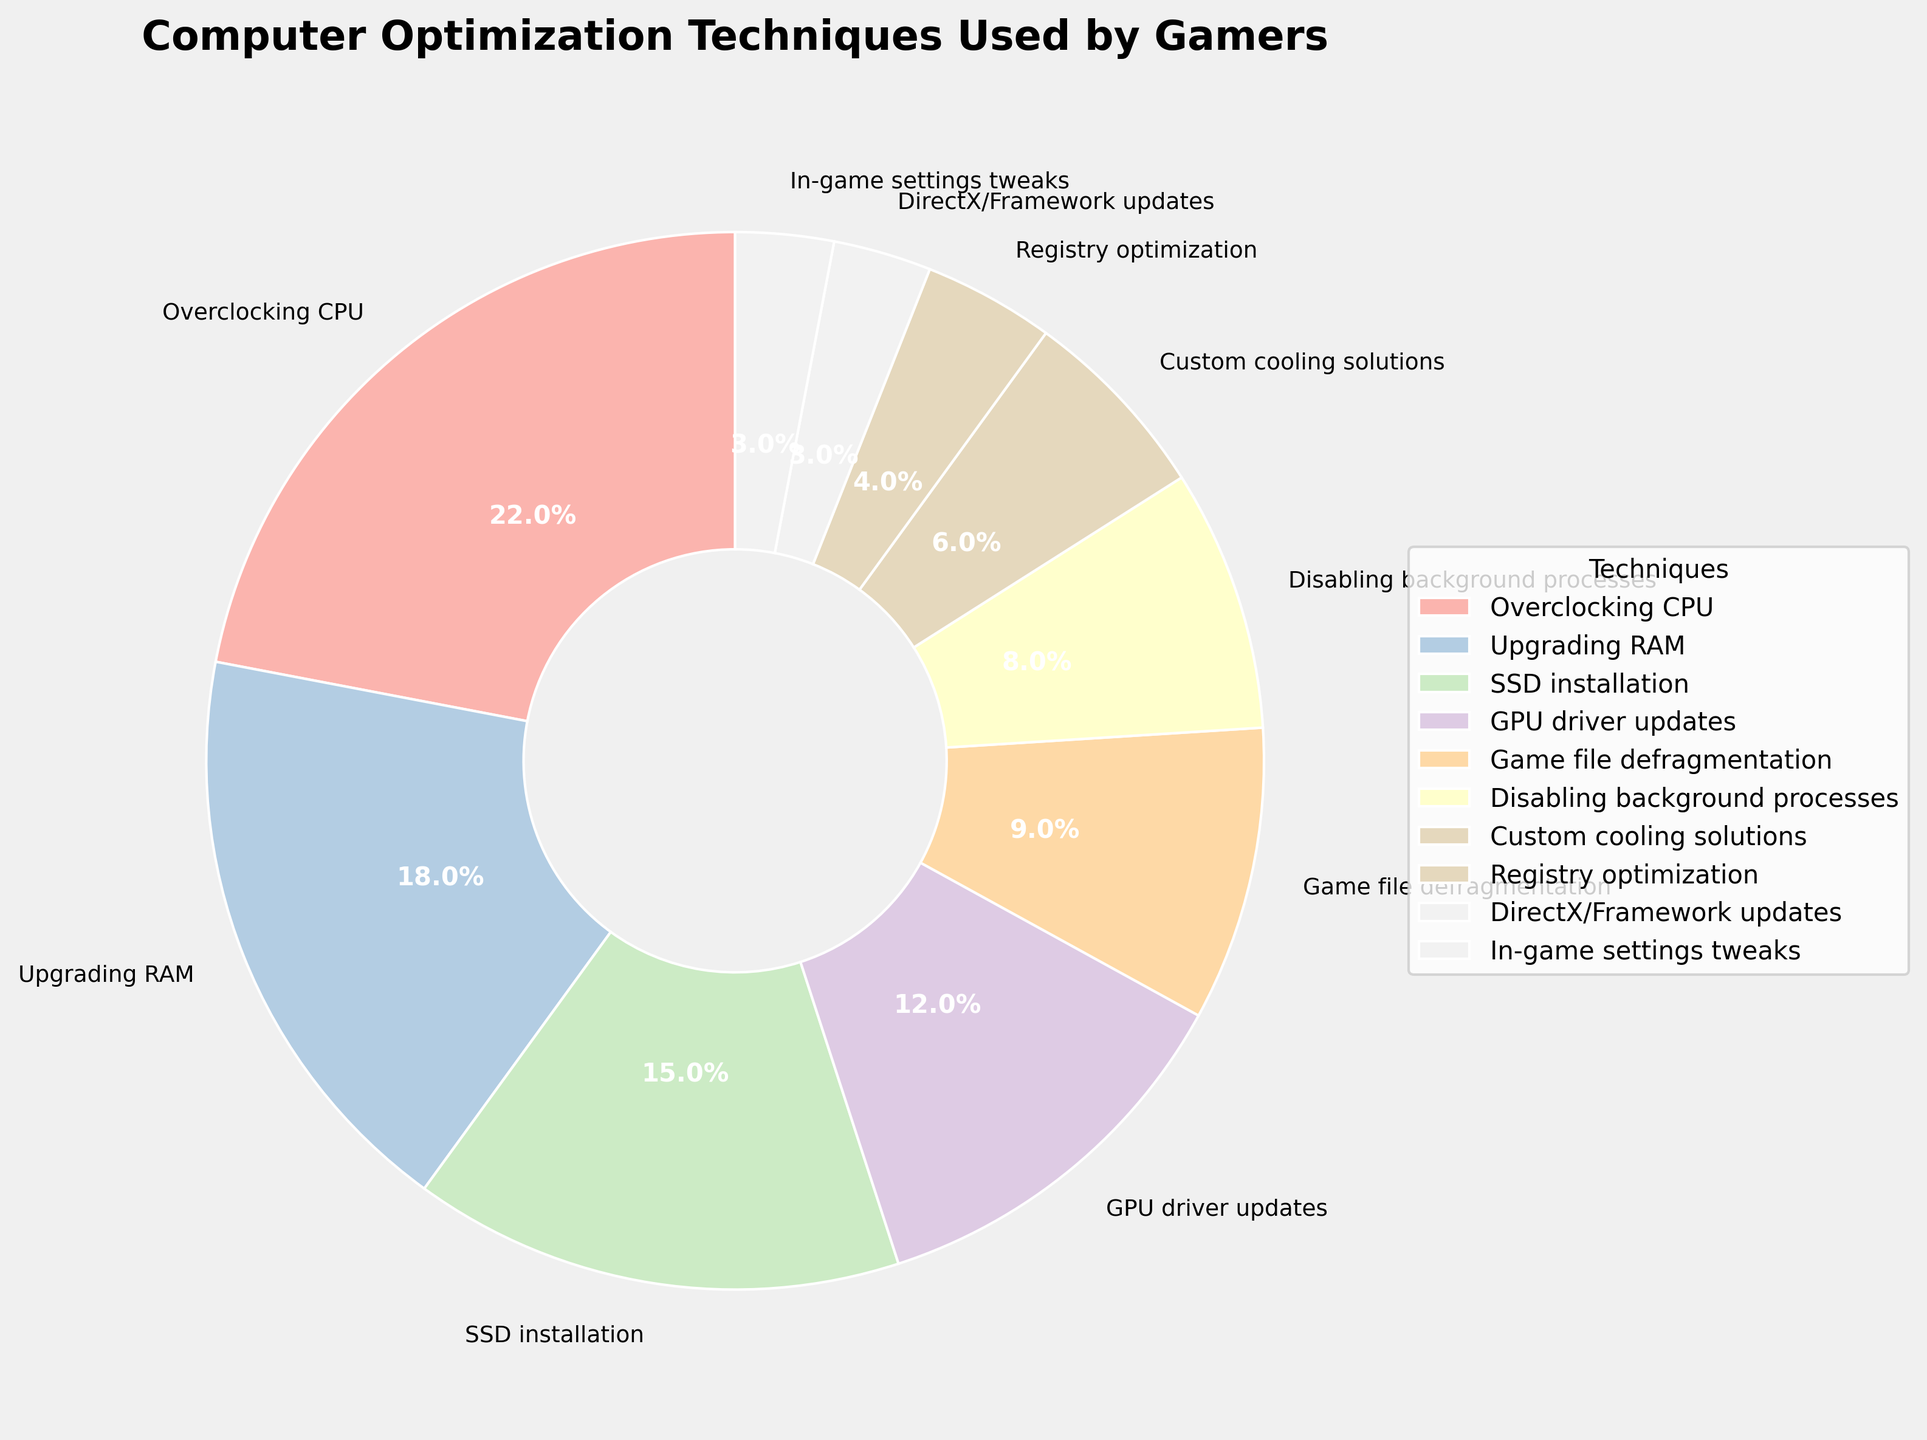What percentage of gamers use SSD installation as an optimization technique? Look at the slice labeled "SSD installation" and find its percentage.
Answer: 15% Which technique is used by more gamers, upgrading RAM or GPU driver updates? Compare the percentages of "Upgrading RAM" and "GPU driver updates". RAM has 18%, GPU drivers have 12%.
Answer: Upgrading RAM What’s the total percentage of gamers that use overclocking CPU, upgrading RAM, and SSD installation? Sum the percentages of "Overclocking CPU (22%)", "Upgrading RAM (18%)", and "SSD installation (15%)". So, 22 + 18 + 15 = 55%.
Answer: 55% Are there any techniques used by less than 5% of gamers? If so, which ones? Scan the slices for percentages less than 5%. Both "Registry optimization" and "In-game settings tweaks" are at 4% and 3% respectively.
Answer: Registry optimization, In-game settings tweaks What percentage of gamers use techniques related to cooling solutions and what visually distinguishes that slice? The percentage for "Custom cooling solutions" is 6%. Visually, it’s differentiated by its color in the pie chart.
Answer: 6% What’s the difference in percentage between the technique used by the most gamers and the technique used by the least gamers? Subtract the smallest percentage (3%) from the largest percentage (22%). 22 – 3 = 19%.
Answer: 19% How many techniques are utilized by at least 10% of gamers? Identify the techniques with percentages >= 10%. They are "Overclocking CPU (22%)", "Upgrading RAM (18%)", "SSD installation (15%)", and "GPU driver updates (12%)", making it four techniques.
Answer: 4 Between disabling background processes and game file defragmentation, which technique is less frequently used and by what percentage difference? Compare the percentages for "Disabling background processes (8%)" and "Game file defragmentation (9%)". The difference is 9-8 = 1%.
Answer: Disabling background processes, 1% 